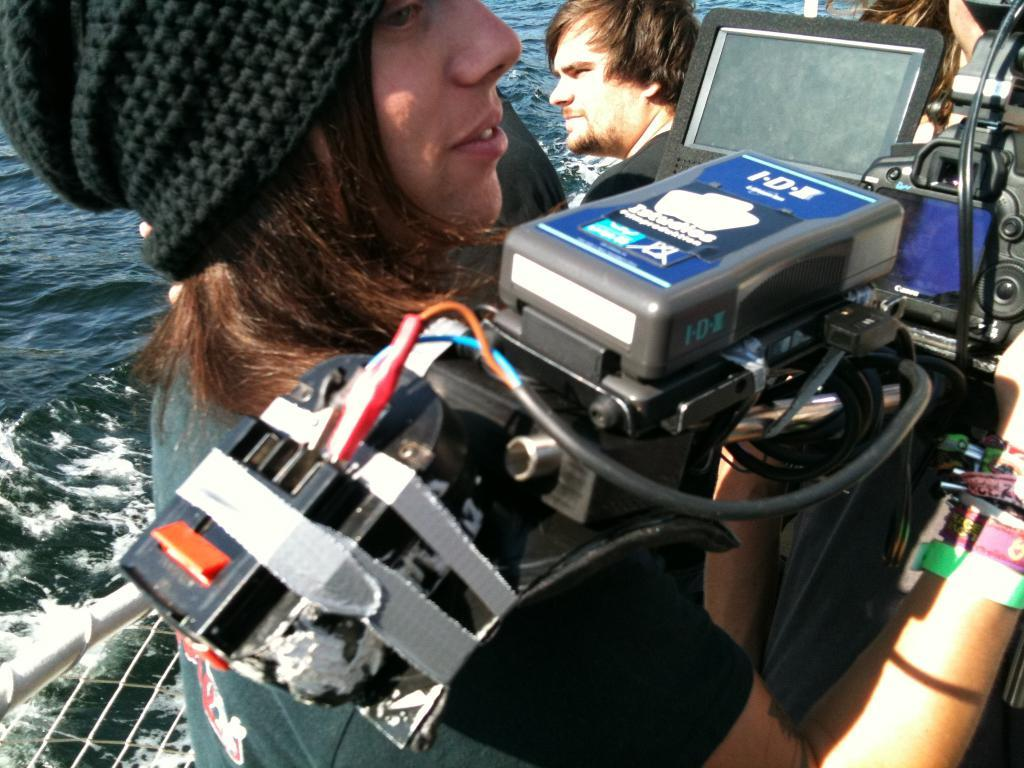What is visible in the image? There is water visible in the image. How many people are present in the image? There are two persons in the image. What object can be seen in the image besides the water? There is a device and a mesh in the image. What type of cake is being served to the birds in the image? There are no birds or cake present in the image. What property is being discussed in the image? There is no discussion of property in the image. 